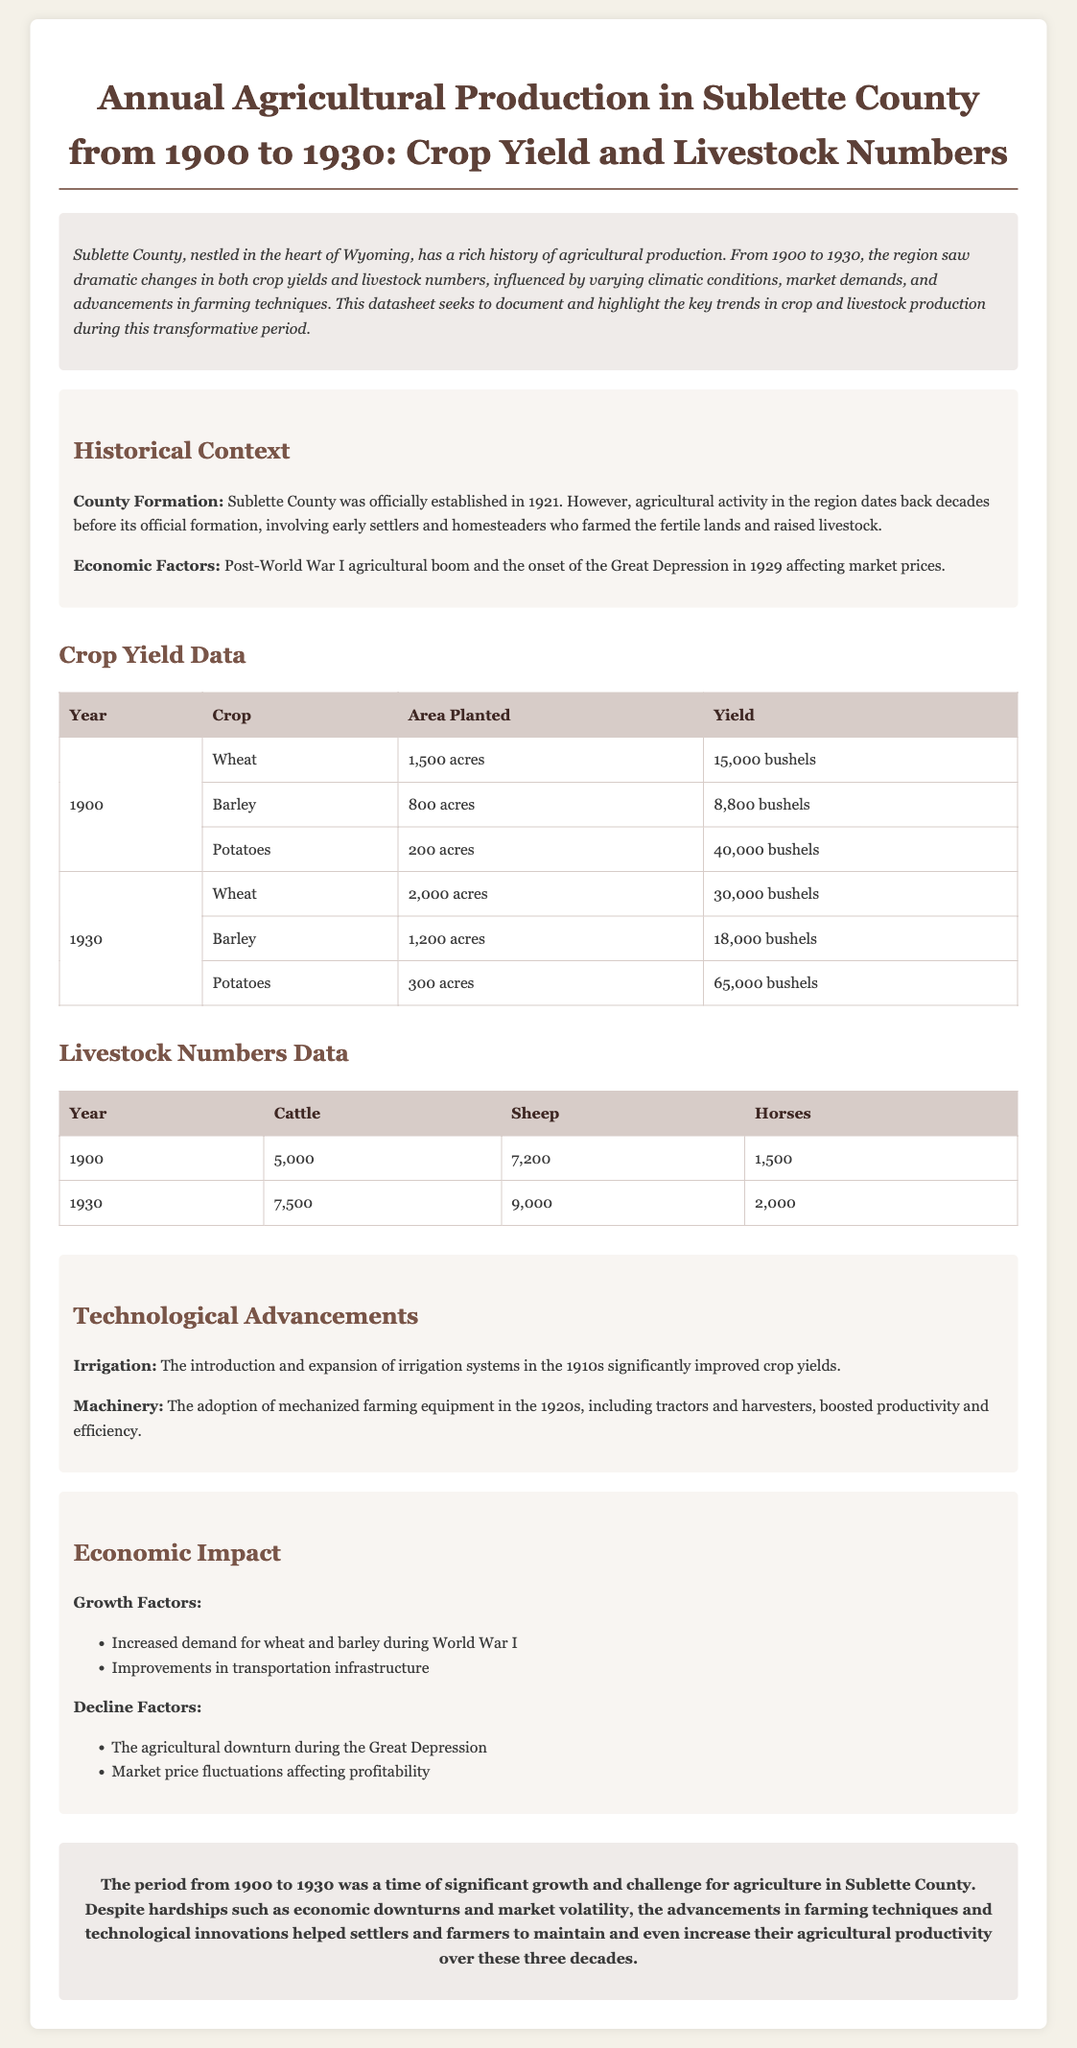What year was Sublette County officially established? The document states that Sublette County was officially established in 1921.
Answer: 1921 How many acres were planted with potatoes in 1900? The crop yield data indicates that 200 acres were planted with potatoes in 1900.
Answer: 200 acres What was the yield of wheat in 1930? According to the data, the yield of wheat in 1930 was 30,000 bushels.
Answer: 30,000 bushels What was the number of cattle in Sublette County in 1900? The livestock numbers data shows that there were 5,000 cattle in 1900.
Answer: 5,000 What advancement significantly improved crop yields in the 1910s? The document mentions that the introduction and expansion of irrigation systems significantly improved crop yields.
Answer: Irrigation systems What economic factor affected agricultural prices in 1929? The document refers to the onset of the Great Depression in 1929 affecting market prices.
Answer: Great Depression How many sheep were there in 1930? From the livestock numbers data, there were 9,000 sheep in 1930.
Answer: 9,000 What contributed to the agricultural downturn during the 1930s? The document lists the agricultural downturn during the Great Depression as a decline factor.
Answer: Great Depression 